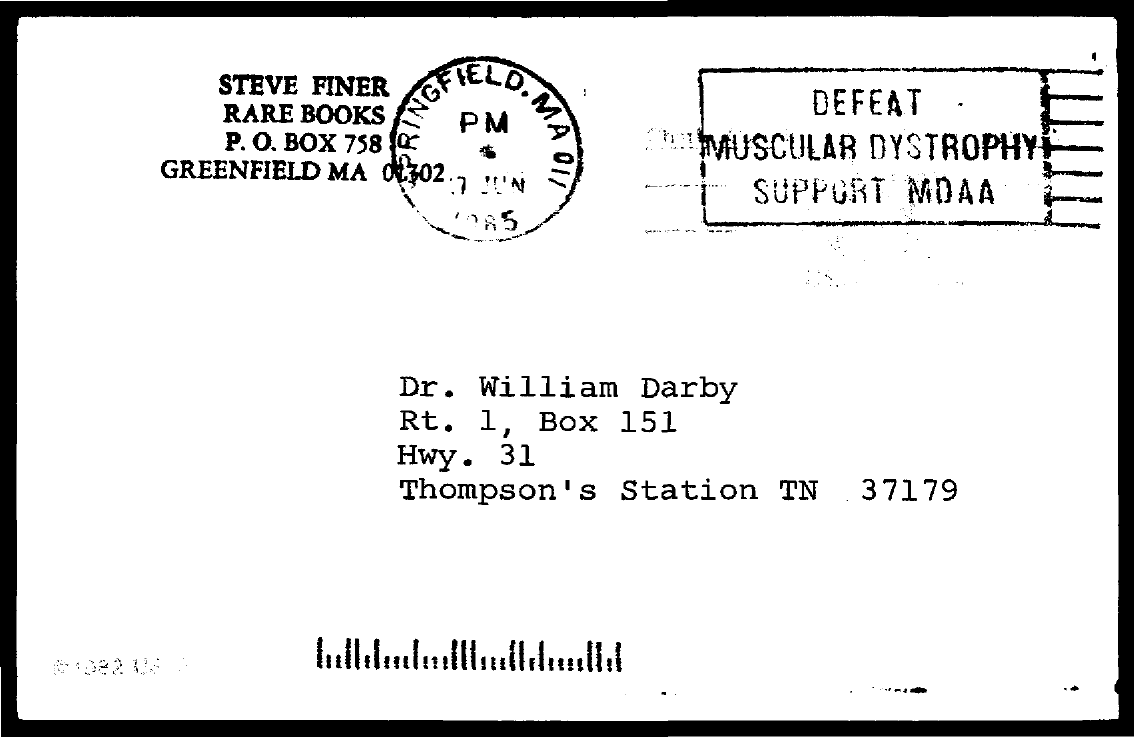What is the PO Box Number of Steve Finer Rare Books?
Ensure brevity in your answer.  758. 